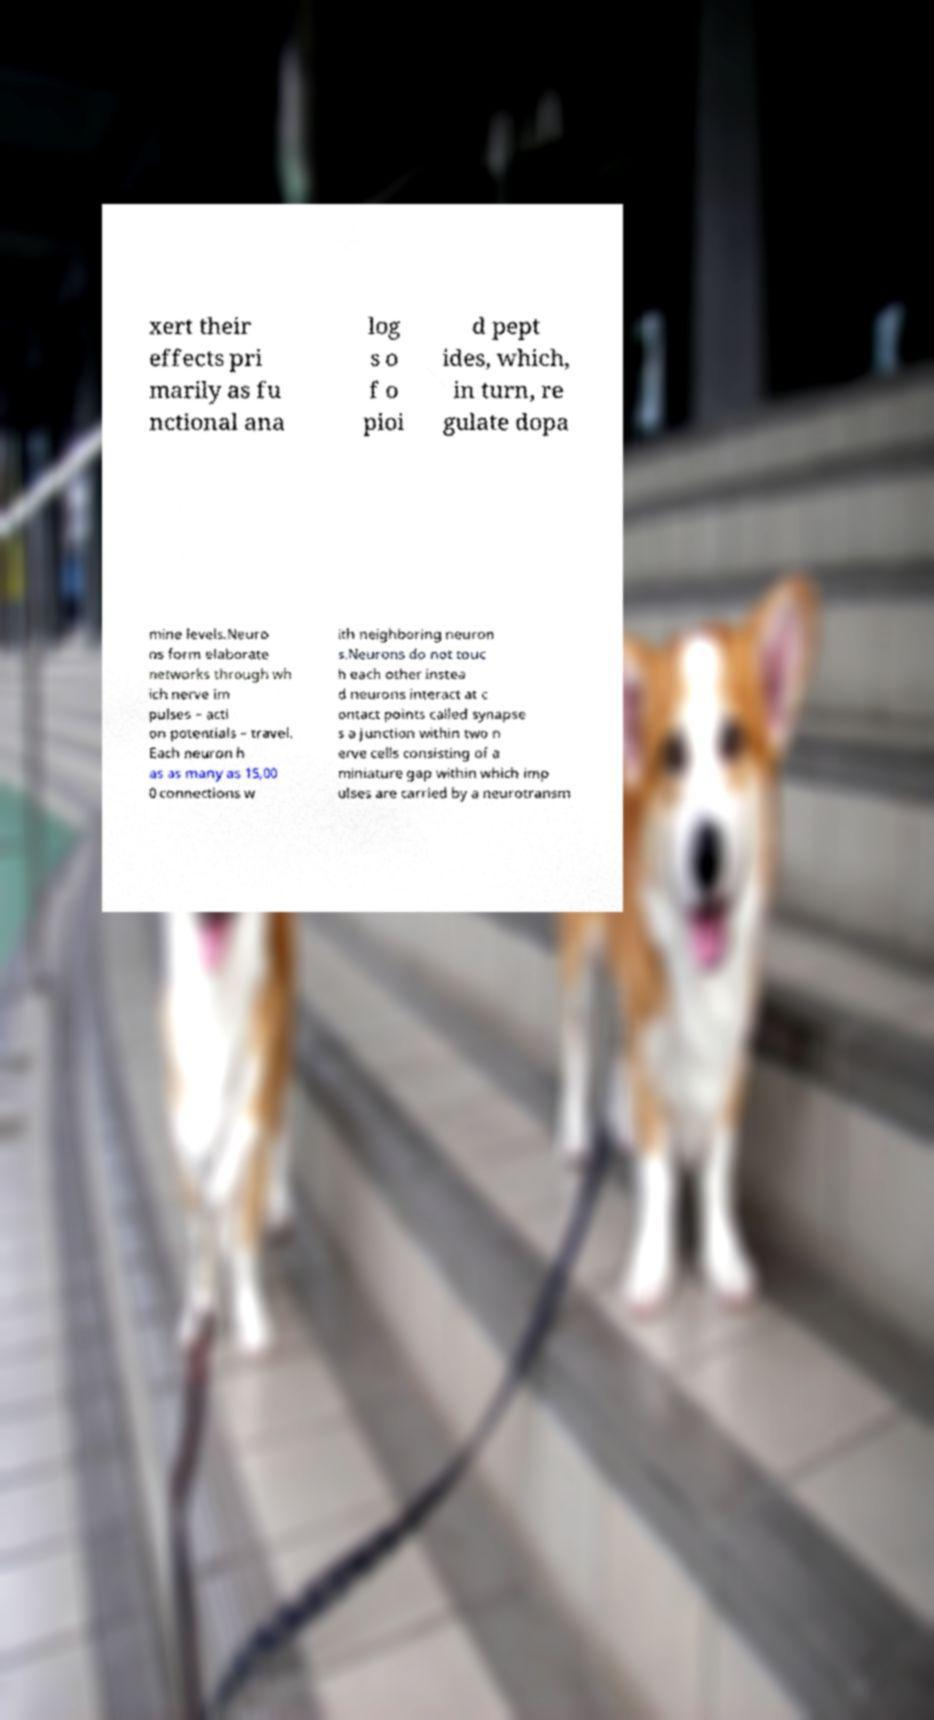Can you read and provide the text displayed in the image?This photo seems to have some interesting text. Can you extract and type it out for me? xert their effects pri marily as fu nctional ana log s o f o pioi d pept ides, which, in turn, re gulate dopa mine levels.Neuro ns form elaborate networks through wh ich nerve im pulses – acti on potentials – travel. Each neuron h as as many as 15,00 0 connections w ith neighboring neuron s.Neurons do not touc h each other instea d neurons interact at c ontact points called synapse s a junction within two n erve cells consisting of a miniature gap within which imp ulses are carried by a neurotransm 